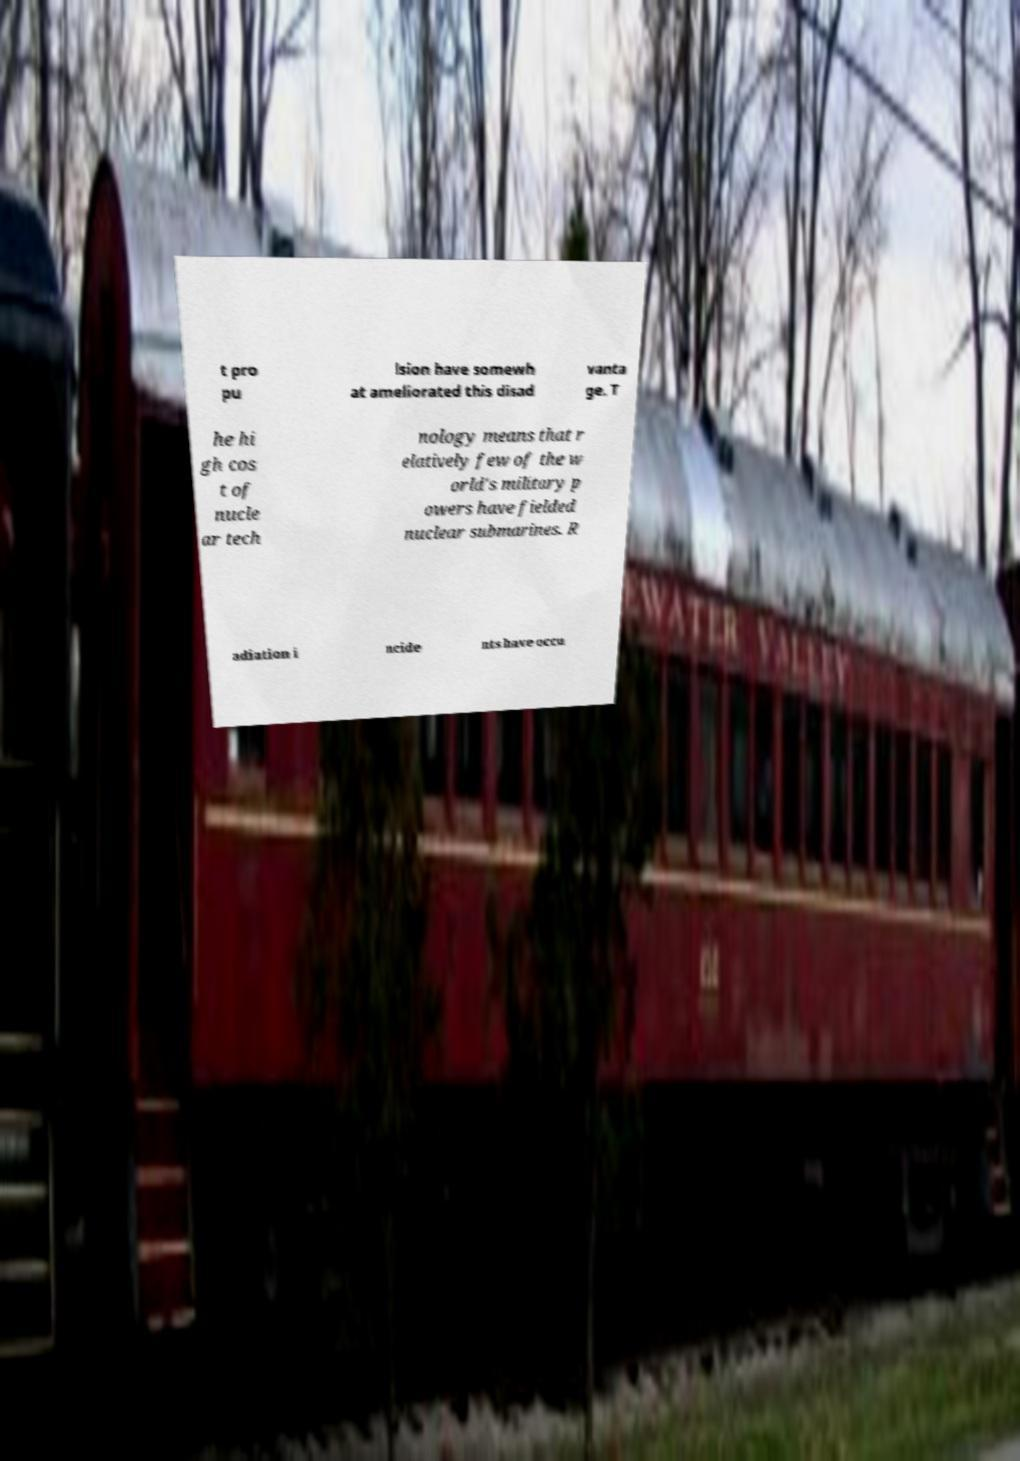Please read and relay the text visible in this image. What does it say? t pro pu lsion have somewh at ameliorated this disad vanta ge. T he hi gh cos t of nucle ar tech nology means that r elatively few of the w orld's military p owers have fielded nuclear submarines. R adiation i ncide nts have occu 